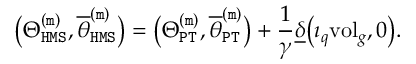<formula> <loc_0><loc_0><loc_500><loc_500>\left ( \Theta _ { H M S } ^ { ( m ) } , \overline { \theta } _ { H M S } ^ { ( m ) } \right ) = \left ( \Theta _ { P T } ^ { ( m ) } , \overline { \theta } _ { P T } ^ { ( m ) } \right ) + \frac { 1 } { \gamma } \underline { \delta } \left ( \imath _ { q } v o l _ { g } , 0 \right ) .</formula> 